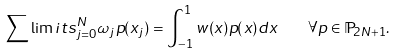<formula> <loc_0><loc_0><loc_500><loc_500>\sum \lim i t s _ { j = 0 } ^ { N } \omega _ { j } p ( x _ { j } ) = \int _ { - 1 } ^ { 1 } w ( x ) p ( x ) d x \quad \forall p \in \mathbb { P } _ { 2 N + 1 } .</formula> 